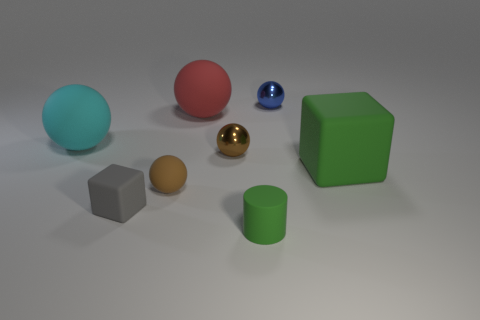There is a brown shiny object that is the same shape as the brown rubber thing; what is its size?
Provide a succinct answer. Small. There is a green matte cube; does it have the same size as the metal object that is to the right of the rubber cylinder?
Your response must be concise. No. There is a large matte sphere that is left of the tiny rubber cube; is there a small green rubber cylinder on the left side of it?
Your answer should be very brief. No. What is the shape of the small gray rubber object that is to the right of the large cyan object?
Make the answer very short. Cube. There is a tiny cylinder that is the same color as the large matte cube; what material is it?
Your answer should be compact. Rubber. There is a block in front of the big green block that is behind the green cylinder; what is its color?
Your answer should be very brief. Gray. Is the gray matte object the same size as the red sphere?
Offer a very short reply. No. What material is the green thing that is the same shape as the gray thing?
Make the answer very short. Rubber. What number of other blue balls are the same size as the blue sphere?
Give a very brief answer. 0. The tiny thing that is made of the same material as the tiny blue sphere is what color?
Give a very brief answer. Brown. 